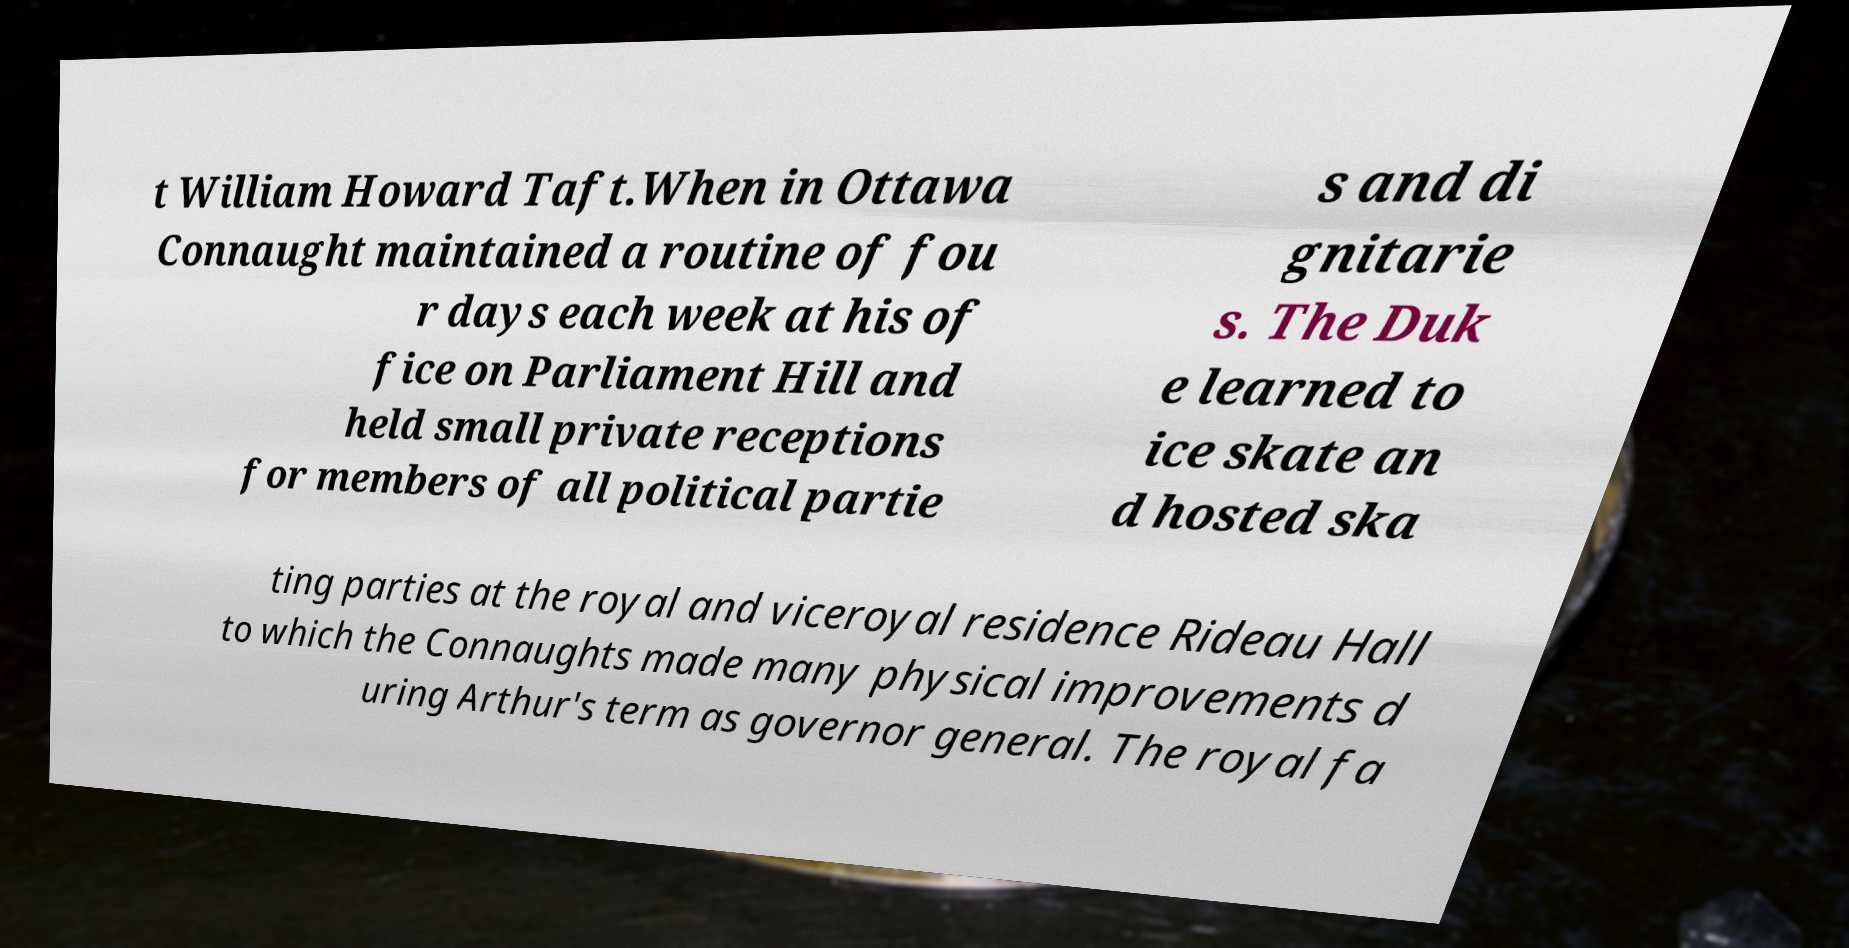Can you accurately transcribe the text from the provided image for me? t William Howard Taft.When in Ottawa Connaught maintained a routine of fou r days each week at his of fice on Parliament Hill and held small private receptions for members of all political partie s and di gnitarie s. The Duk e learned to ice skate an d hosted ska ting parties at the royal and viceroyal residence Rideau Hall to which the Connaughts made many physical improvements d uring Arthur's term as governor general. The royal fa 